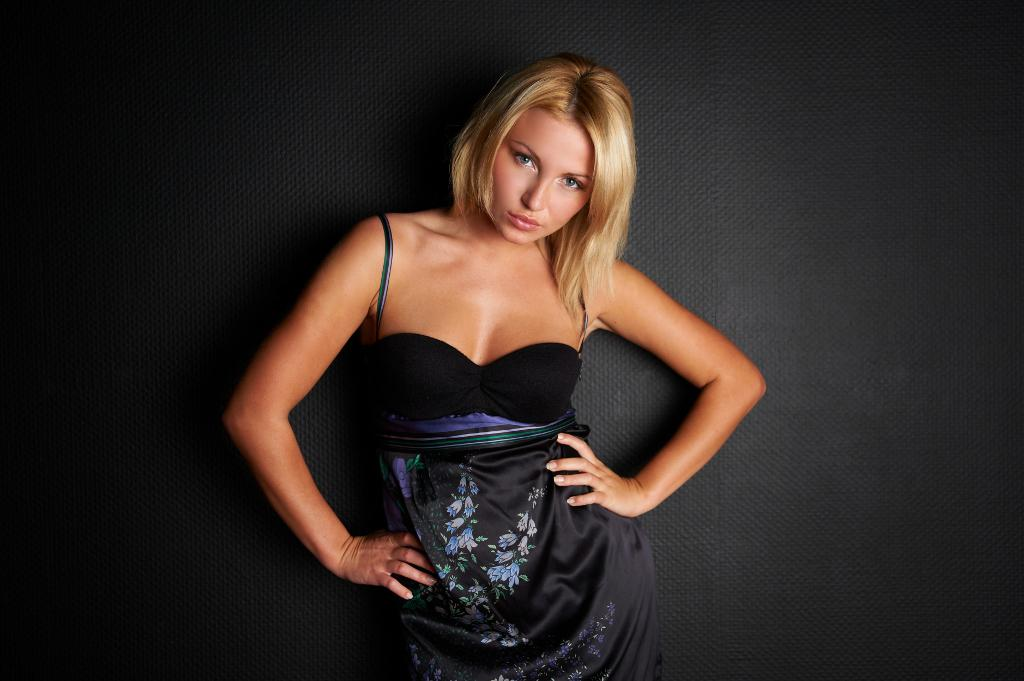Who is the main subject in the image? There is a woman in the image. What is the woman wearing? The woman is wearing a black dress. What is the color of the background in the image? The background of the image is black in color. How many actors are present in the image? There are no actors present in the image; it features a woman wearing a black dress against a black background. What type of nose can be seen on the men in the image? There are no men present in the image, and therefore no noses can be observed. 